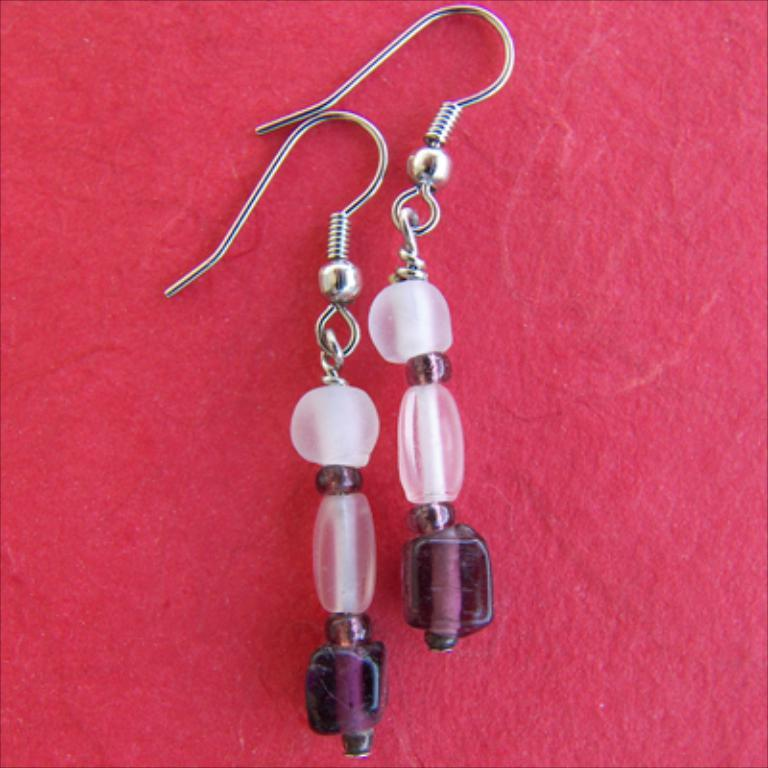What type of accessory is featured in the image? There is a pair of earrings in the image. What is the color of the surface on which the earrings are placed? The pair of earrings is on a red surface. How many geese are present in the image? There are no geese present in the image; it features a pair of earrings on a red surface. 